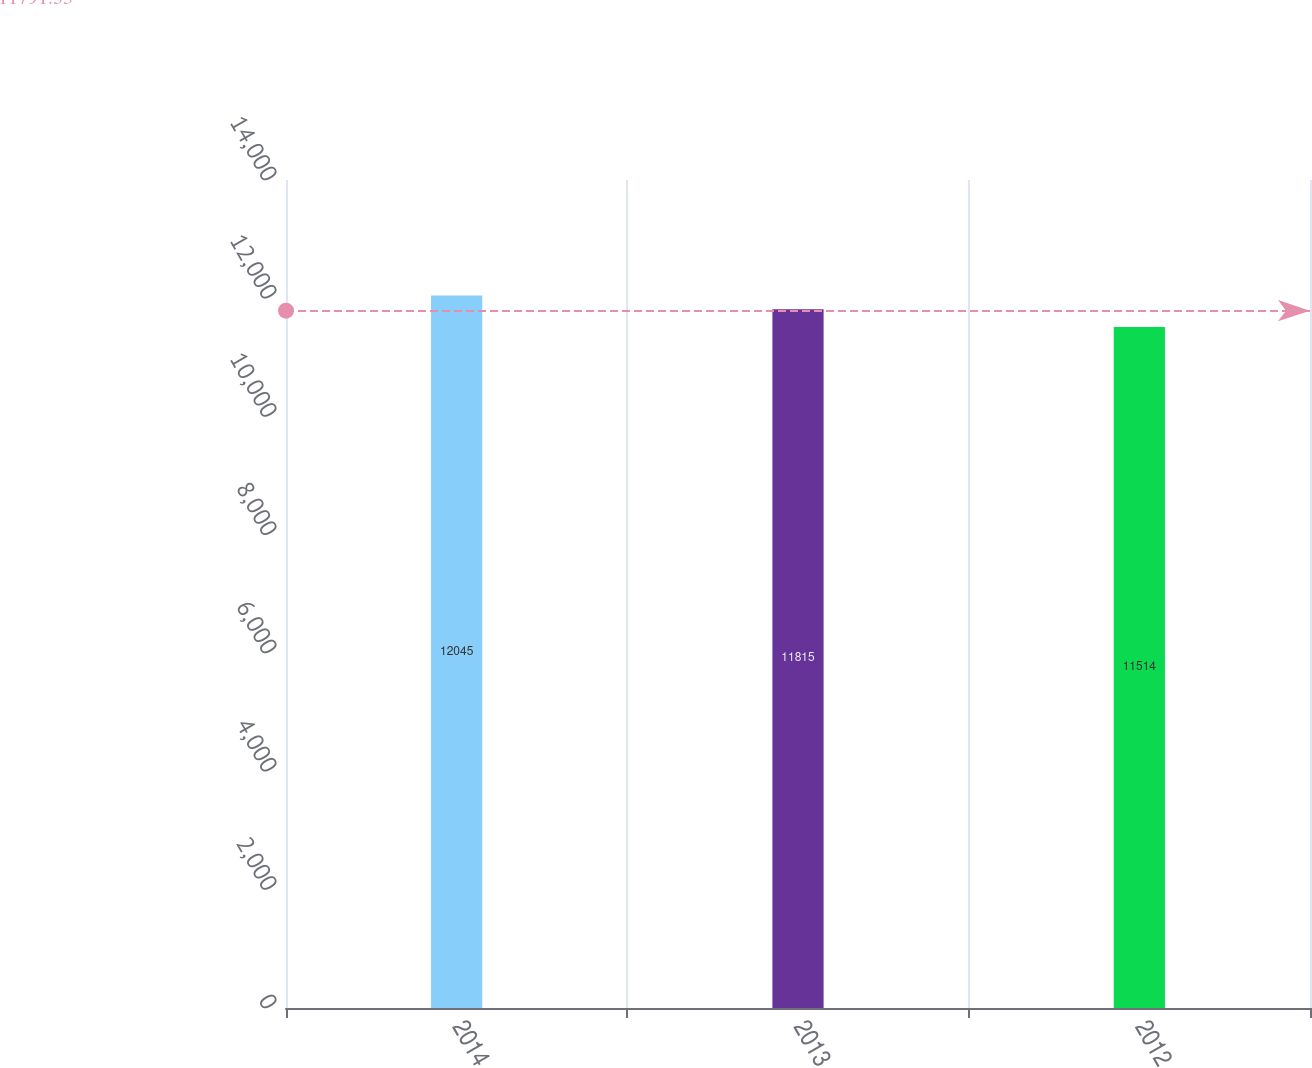Convert chart to OTSL. <chart><loc_0><loc_0><loc_500><loc_500><bar_chart><fcel>2014<fcel>2013<fcel>2012<nl><fcel>12045<fcel>11815<fcel>11514<nl></chart> 